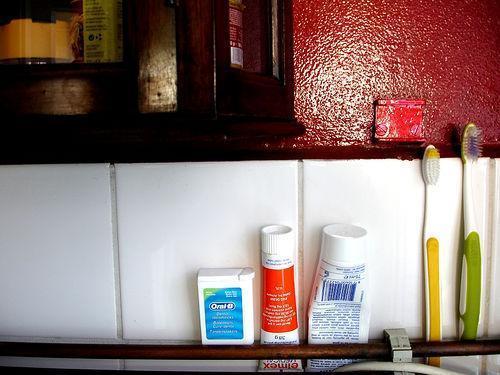How many toothbrushes are there?
Give a very brief answer. 2. 